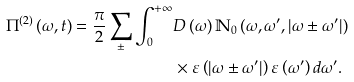Convert formula to latex. <formula><loc_0><loc_0><loc_500><loc_500>\Pi ^ { \left ( 2 \right ) } \left ( \omega , t \right ) = \frac { \pi } { 2 } \sum _ { \pm } \int _ { 0 } ^ { + \infty } & D \left ( \omega \right ) \mathbb { N } _ { 0 } \left ( \omega , \omega ^ { \prime } , \left | \omega \pm \omega ^ { \prime } \right | \right ) \\ & \times \varepsilon \left ( \left | \omega \pm \omega ^ { \prime } \right | \right ) \varepsilon \left ( \omega ^ { \prime } \right ) d \omega ^ { \prime } .</formula> 